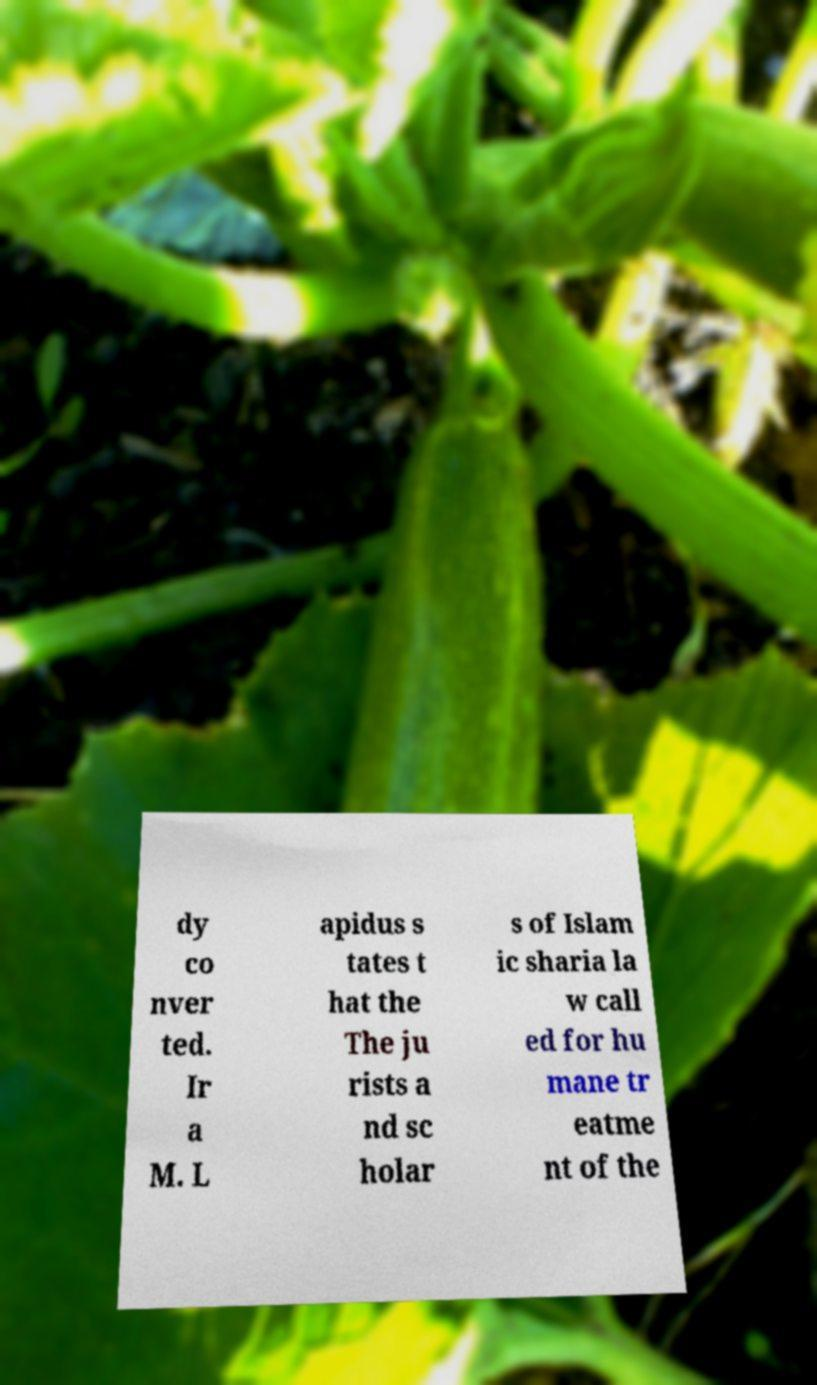Please identify and transcribe the text found in this image. dy co nver ted. Ir a M. L apidus s tates t hat the The ju rists a nd sc holar s of Islam ic sharia la w call ed for hu mane tr eatme nt of the 